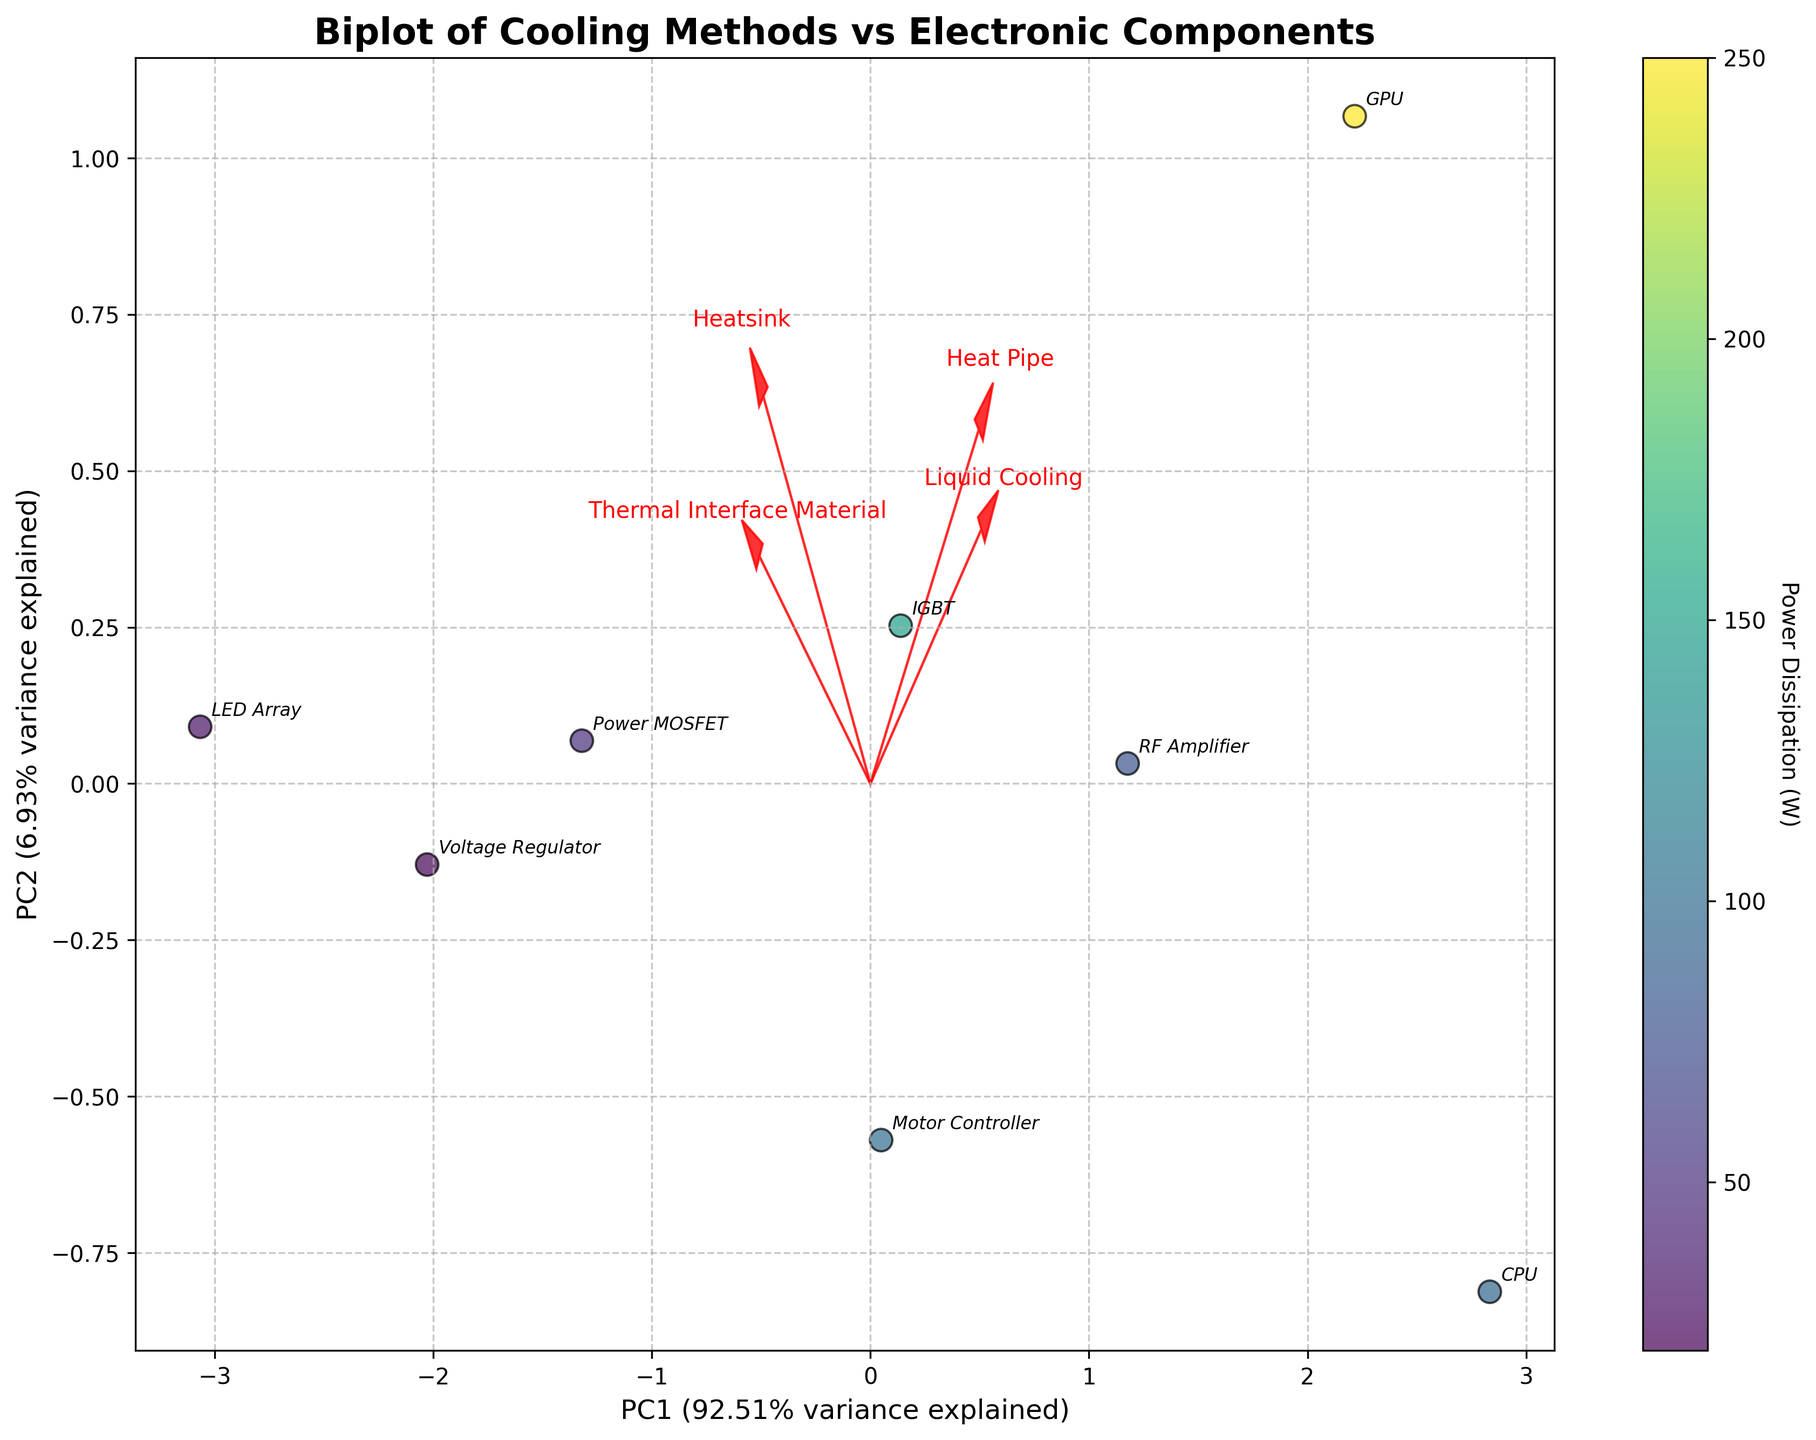What is the title of the plot? The title of the plot is typically displayed at the top center of the figure.
Answer: Biplot of Cooling Methods vs Electronic Components How many different electronic component types are represented in the plot? Each component represented is marked with an annotation of the component names. Counting these annotations provides the total.
Answer: 8 Which cooling method has the most influence along PC1 axis based on the length of its vector? The length of the vectors indicates the influence of each cooling method. Compare the lengths of all vectors along PC1.
Answer: Liquid Cooling Which component appears to have the highest power dissipation based on the color and scatter size? The scatter points are colored and possibly sized according to power dissipation. The darkest/most intense color or largest scatter size corresponds to highest power dissipation.
Answer: GPU What is the approximate percentage of variance explained by PC1? The percentage of variance explained by PC1 is included in the x-axis label.
Answer: Around 52.3% Which two cooling methods contribute similarly along PC2? Look at the arrows for cooling methods and compare their lengths and directions along the PC2 axis. Two arrows close in length and direction along PC2 contribute similarly.
Answer: Heatsink and Thermal Interface Material How do Heat Pipe and Voltage Regulator relate to each other in the plot? Locate both Heat Pipe and Voltage Regulator in the biplot. Examine their positions in PC1 and PC2.
Answer: Heat Pipe is more positively correlated with PC1 and PC2 than Voltage Regulator Which cooling method is more positively correlated with PC2: Heat Pipe or Thermal Interface Material? Check the direction and length of the vectors for each cooling method along PC2. Find which one is longer and positively oriented along PC2.
Answer: Thermal Interface Material Does the CPU component have a higher or lower score on PC1 compared to the RF Amplifier? Locate the CPU and RF Amplifier on the biplot. Compare their positions along the PC1 axis.
Answer: Higher What is the approximate range of explained variance by PC2? The y-axis label typically mentions the percentage of variance explained by PC2.
Answer: Around 21.4% 